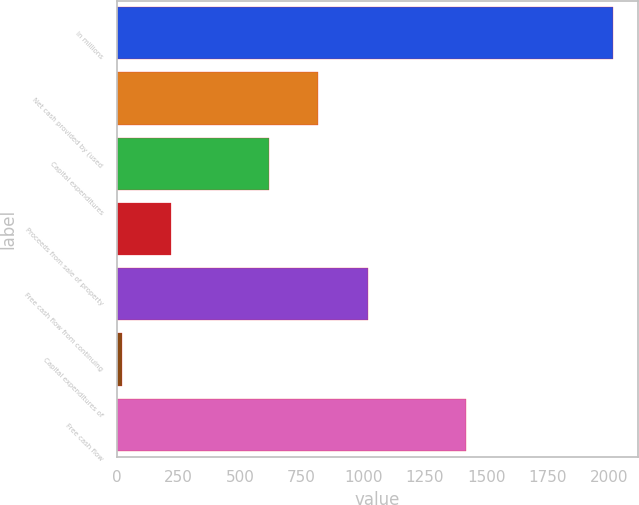Convert chart to OTSL. <chart><loc_0><loc_0><loc_500><loc_500><bar_chart><fcel>In millions<fcel>Net cash provided by (used<fcel>Capital expenditures<fcel>Proceeds from sale of property<fcel>Free cash flow from continuing<fcel>Capital expenditures of<fcel>Free cash flow<nl><fcel>2016<fcel>818.64<fcel>619.08<fcel>219.96<fcel>1018.2<fcel>20.4<fcel>1417.32<nl></chart> 